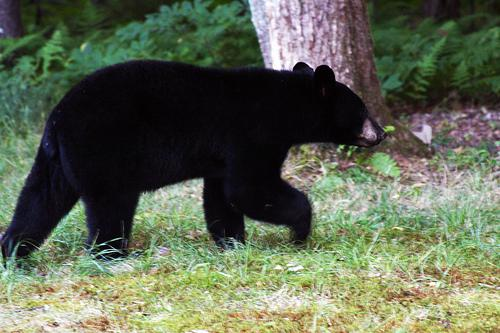Question: what color is the grass?
Choices:
A. Yellow.
B. White.
C. Red.
D. Green.
Answer with the letter. Answer: D Question: where is this shot?
Choices:
A. Outdoors.
B. At the beach.
C. In the theater.
D. Forest.
Answer with the letter. Answer: D Question: how many ears are shown?
Choices:
A. 2.
B. 1.
C. 3.
D. 4.
Answer with the letter. Answer: A 